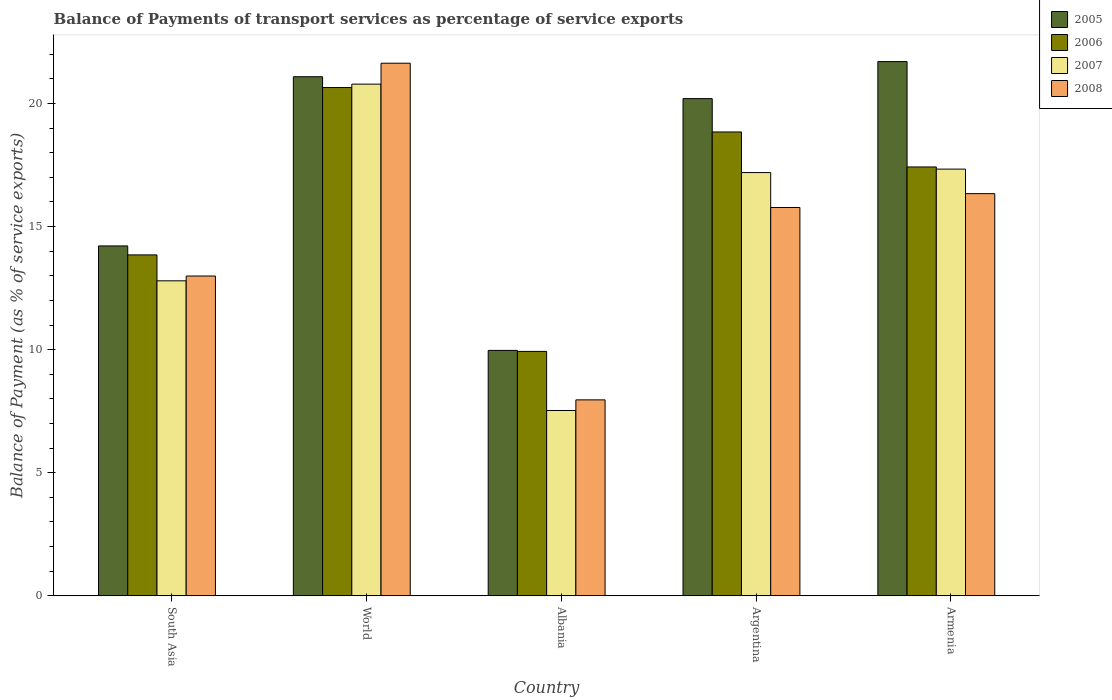How many different coloured bars are there?
Provide a short and direct response. 4. How many groups of bars are there?
Your response must be concise. 5. What is the balance of payments of transport services in 2007 in Argentina?
Ensure brevity in your answer.  17.19. Across all countries, what is the maximum balance of payments of transport services in 2008?
Make the answer very short. 21.64. Across all countries, what is the minimum balance of payments of transport services in 2007?
Offer a terse response. 7.53. In which country was the balance of payments of transport services in 2005 minimum?
Give a very brief answer. Albania. What is the total balance of payments of transport services in 2007 in the graph?
Give a very brief answer. 75.64. What is the difference between the balance of payments of transport services in 2007 in Albania and that in Armenia?
Your response must be concise. -9.81. What is the difference between the balance of payments of transport services in 2008 in South Asia and the balance of payments of transport services in 2005 in Argentina?
Keep it short and to the point. -7.21. What is the average balance of payments of transport services in 2007 per country?
Offer a very short reply. 15.13. What is the difference between the balance of payments of transport services of/in 2007 and balance of payments of transport services of/in 2005 in World?
Offer a terse response. -0.3. What is the ratio of the balance of payments of transport services in 2006 in Argentina to that in South Asia?
Offer a terse response. 1.36. What is the difference between the highest and the second highest balance of payments of transport services in 2008?
Your answer should be very brief. -5.3. What is the difference between the highest and the lowest balance of payments of transport services in 2006?
Ensure brevity in your answer.  10.72. In how many countries, is the balance of payments of transport services in 2006 greater than the average balance of payments of transport services in 2006 taken over all countries?
Keep it short and to the point. 3. Is the sum of the balance of payments of transport services in 2008 in Argentina and World greater than the maximum balance of payments of transport services in 2006 across all countries?
Your response must be concise. Yes. What does the 2nd bar from the right in World represents?
Give a very brief answer. 2007. What is the difference between two consecutive major ticks on the Y-axis?
Make the answer very short. 5. Are the values on the major ticks of Y-axis written in scientific E-notation?
Offer a very short reply. No. Does the graph contain any zero values?
Provide a short and direct response. No. Does the graph contain grids?
Provide a succinct answer. No. Where does the legend appear in the graph?
Ensure brevity in your answer.  Top right. How are the legend labels stacked?
Provide a short and direct response. Vertical. What is the title of the graph?
Ensure brevity in your answer.  Balance of Payments of transport services as percentage of service exports. Does "1979" appear as one of the legend labels in the graph?
Offer a very short reply. No. What is the label or title of the Y-axis?
Your answer should be very brief. Balance of Payment (as % of service exports). What is the Balance of Payment (as % of service exports) in 2005 in South Asia?
Provide a short and direct response. 14.21. What is the Balance of Payment (as % of service exports) of 2006 in South Asia?
Keep it short and to the point. 13.85. What is the Balance of Payment (as % of service exports) in 2007 in South Asia?
Your response must be concise. 12.8. What is the Balance of Payment (as % of service exports) of 2008 in South Asia?
Offer a very short reply. 12.99. What is the Balance of Payment (as % of service exports) in 2005 in World?
Your response must be concise. 21.09. What is the Balance of Payment (as % of service exports) in 2006 in World?
Your answer should be very brief. 20.65. What is the Balance of Payment (as % of service exports) of 2007 in World?
Offer a very short reply. 20.79. What is the Balance of Payment (as % of service exports) of 2008 in World?
Ensure brevity in your answer.  21.64. What is the Balance of Payment (as % of service exports) of 2005 in Albania?
Give a very brief answer. 9.97. What is the Balance of Payment (as % of service exports) in 2006 in Albania?
Ensure brevity in your answer.  9.93. What is the Balance of Payment (as % of service exports) of 2007 in Albania?
Offer a very short reply. 7.53. What is the Balance of Payment (as % of service exports) in 2008 in Albania?
Your answer should be compact. 7.96. What is the Balance of Payment (as % of service exports) of 2005 in Argentina?
Your answer should be very brief. 20.2. What is the Balance of Payment (as % of service exports) in 2006 in Argentina?
Your answer should be very brief. 18.84. What is the Balance of Payment (as % of service exports) of 2007 in Argentina?
Offer a very short reply. 17.19. What is the Balance of Payment (as % of service exports) in 2008 in Argentina?
Your answer should be compact. 15.78. What is the Balance of Payment (as % of service exports) in 2005 in Armenia?
Provide a short and direct response. 21.7. What is the Balance of Payment (as % of service exports) in 2006 in Armenia?
Make the answer very short. 17.42. What is the Balance of Payment (as % of service exports) in 2007 in Armenia?
Keep it short and to the point. 17.34. What is the Balance of Payment (as % of service exports) of 2008 in Armenia?
Keep it short and to the point. 16.34. Across all countries, what is the maximum Balance of Payment (as % of service exports) in 2005?
Your response must be concise. 21.7. Across all countries, what is the maximum Balance of Payment (as % of service exports) of 2006?
Ensure brevity in your answer.  20.65. Across all countries, what is the maximum Balance of Payment (as % of service exports) in 2007?
Ensure brevity in your answer.  20.79. Across all countries, what is the maximum Balance of Payment (as % of service exports) of 2008?
Give a very brief answer. 21.64. Across all countries, what is the minimum Balance of Payment (as % of service exports) of 2005?
Provide a short and direct response. 9.97. Across all countries, what is the minimum Balance of Payment (as % of service exports) of 2006?
Provide a succinct answer. 9.93. Across all countries, what is the minimum Balance of Payment (as % of service exports) of 2007?
Offer a terse response. 7.53. Across all countries, what is the minimum Balance of Payment (as % of service exports) in 2008?
Keep it short and to the point. 7.96. What is the total Balance of Payment (as % of service exports) in 2005 in the graph?
Give a very brief answer. 87.17. What is the total Balance of Payment (as % of service exports) in 2006 in the graph?
Keep it short and to the point. 80.69. What is the total Balance of Payment (as % of service exports) in 2007 in the graph?
Provide a short and direct response. 75.64. What is the total Balance of Payment (as % of service exports) of 2008 in the graph?
Offer a very short reply. 74.7. What is the difference between the Balance of Payment (as % of service exports) in 2005 in South Asia and that in World?
Provide a short and direct response. -6.87. What is the difference between the Balance of Payment (as % of service exports) in 2006 in South Asia and that in World?
Keep it short and to the point. -6.8. What is the difference between the Balance of Payment (as % of service exports) of 2007 in South Asia and that in World?
Give a very brief answer. -7.99. What is the difference between the Balance of Payment (as % of service exports) in 2008 in South Asia and that in World?
Your response must be concise. -8.64. What is the difference between the Balance of Payment (as % of service exports) in 2005 in South Asia and that in Albania?
Ensure brevity in your answer.  4.24. What is the difference between the Balance of Payment (as % of service exports) in 2006 in South Asia and that in Albania?
Your answer should be compact. 3.92. What is the difference between the Balance of Payment (as % of service exports) in 2007 in South Asia and that in Albania?
Keep it short and to the point. 5.27. What is the difference between the Balance of Payment (as % of service exports) of 2008 in South Asia and that in Albania?
Give a very brief answer. 5.03. What is the difference between the Balance of Payment (as % of service exports) in 2005 in South Asia and that in Argentina?
Give a very brief answer. -5.98. What is the difference between the Balance of Payment (as % of service exports) in 2006 in South Asia and that in Argentina?
Offer a terse response. -4.99. What is the difference between the Balance of Payment (as % of service exports) in 2007 in South Asia and that in Argentina?
Provide a short and direct response. -4.4. What is the difference between the Balance of Payment (as % of service exports) of 2008 in South Asia and that in Argentina?
Provide a succinct answer. -2.78. What is the difference between the Balance of Payment (as % of service exports) of 2005 in South Asia and that in Armenia?
Give a very brief answer. -7.49. What is the difference between the Balance of Payment (as % of service exports) of 2006 in South Asia and that in Armenia?
Give a very brief answer. -3.57. What is the difference between the Balance of Payment (as % of service exports) of 2007 in South Asia and that in Armenia?
Make the answer very short. -4.54. What is the difference between the Balance of Payment (as % of service exports) in 2008 in South Asia and that in Armenia?
Ensure brevity in your answer.  -3.35. What is the difference between the Balance of Payment (as % of service exports) of 2005 in World and that in Albania?
Your answer should be compact. 11.12. What is the difference between the Balance of Payment (as % of service exports) in 2006 in World and that in Albania?
Give a very brief answer. 10.72. What is the difference between the Balance of Payment (as % of service exports) in 2007 in World and that in Albania?
Provide a short and direct response. 13.26. What is the difference between the Balance of Payment (as % of service exports) in 2008 in World and that in Albania?
Give a very brief answer. 13.68. What is the difference between the Balance of Payment (as % of service exports) of 2005 in World and that in Argentina?
Provide a short and direct response. 0.89. What is the difference between the Balance of Payment (as % of service exports) of 2006 in World and that in Argentina?
Offer a very short reply. 1.8. What is the difference between the Balance of Payment (as % of service exports) of 2007 in World and that in Argentina?
Your answer should be compact. 3.59. What is the difference between the Balance of Payment (as % of service exports) of 2008 in World and that in Argentina?
Provide a short and direct response. 5.86. What is the difference between the Balance of Payment (as % of service exports) in 2005 in World and that in Armenia?
Your answer should be very brief. -0.62. What is the difference between the Balance of Payment (as % of service exports) in 2006 in World and that in Armenia?
Offer a very short reply. 3.23. What is the difference between the Balance of Payment (as % of service exports) in 2007 in World and that in Armenia?
Offer a terse response. 3.45. What is the difference between the Balance of Payment (as % of service exports) of 2008 in World and that in Armenia?
Your response must be concise. 5.3. What is the difference between the Balance of Payment (as % of service exports) of 2005 in Albania and that in Argentina?
Make the answer very short. -10.23. What is the difference between the Balance of Payment (as % of service exports) in 2006 in Albania and that in Argentina?
Offer a very short reply. -8.91. What is the difference between the Balance of Payment (as % of service exports) of 2007 in Albania and that in Argentina?
Give a very brief answer. -9.67. What is the difference between the Balance of Payment (as % of service exports) of 2008 in Albania and that in Argentina?
Offer a terse response. -7.81. What is the difference between the Balance of Payment (as % of service exports) in 2005 in Albania and that in Armenia?
Your response must be concise. -11.73. What is the difference between the Balance of Payment (as % of service exports) of 2006 in Albania and that in Armenia?
Make the answer very short. -7.49. What is the difference between the Balance of Payment (as % of service exports) in 2007 in Albania and that in Armenia?
Your answer should be very brief. -9.81. What is the difference between the Balance of Payment (as % of service exports) in 2008 in Albania and that in Armenia?
Provide a succinct answer. -8.38. What is the difference between the Balance of Payment (as % of service exports) in 2005 in Argentina and that in Armenia?
Provide a succinct answer. -1.5. What is the difference between the Balance of Payment (as % of service exports) in 2006 in Argentina and that in Armenia?
Provide a succinct answer. 1.42. What is the difference between the Balance of Payment (as % of service exports) of 2007 in Argentina and that in Armenia?
Offer a very short reply. -0.14. What is the difference between the Balance of Payment (as % of service exports) in 2008 in Argentina and that in Armenia?
Your response must be concise. -0.56. What is the difference between the Balance of Payment (as % of service exports) of 2005 in South Asia and the Balance of Payment (as % of service exports) of 2006 in World?
Make the answer very short. -6.43. What is the difference between the Balance of Payment (as % of service exports) of 2005 in South Asia and the Balance of Payment (as % of service exports) of 2007 in World?
Ensure brevity in your answer.  -6.57. What is the difference between the Balance of Payment (as % of service exports) in 2005 in South Asia and the Balance of Payment (as % of service exports) in 2008 in World?
Give a very brief answer. -7.42. What is the difference between the Balance of Payment (as % of service exports) of 2006 in South Asia and the Balance of Payment (as % of service exports) of 2007 in World?
Give a very brief answer. -6.94. What is the difference between the Balance of Payment (as % of service exports) in 2006 in South Asia and the Balance of Payment (as % of service exports) in 2008 in World?
Make the answer very short. -7.79. What is the difference between the Balance of Payment (as % of service exports) in 2007 in South Asia and the Balance of Payment (as % of service exports) in 2008 in World?
Provide a short and direct response. -8.84. What is the difference between the Balance of Payment (as % of service exports) in 2005 in South Asia and the Balance of Payment (as % of service exports) in 2006 in Albania?
Give a very brief answer. 4.28. What is the difference between the Balance of Payment (as % of service exports) in 2005 in South Asia and the Balance of Payment (as % of service exports) in 2007 in Albania?
Offer a very short reply. 6.68. What is the difference between the Balance of Payment (as % of service exports) in 2005 in South Asia and the Balance of Payment (as % of service exports) in 2008 in Albania?
Your answer should be compact. 6.25. What is the difference between the Balance of Payment (as % of service exports) in 2006 in South Asia and the Balance of Payment (as % of service exports) in 2007 in Albania?
Your answer should be very brief. 6.32. What is the difference between the Balance of Payment (as % of service exports) of 2006 in South Asia and the Balance of Payment (as % of service exports) of 2008 in Albania?
Offer a terse response. 5.89. What is the difference between the Balance of Payment (as % of service exports) of 2007 in South Asia and the Balance of Payment (as % of service exports) of 2008 in Albania?
Give a very brief answer. 4.84. What is the difference between the Balance of Payment (as % of service exports) in 2005 in South Asia and the Balance of Payment (as % of service exports) in 2006 in Argentina?
Ensure brevity in your answer.  -4.63. What is the difference between the Balance of Payment (as % of service exports) in 2005 in South Asia and the Balance of Payment (as % of service exports) in 2007 in Argentina?
Give a very brief answer. -2.98. What is the difference between the Balance of Payment (as % of service exports) of 2005 in South Asia and the Balance of Payment (as % of service exports) of 2008 in Argentina?
Offer a terse response. -1.56. What is the difference between the Balance of Payment (as % of service exports) of 2006 in South Asia and the Balance of Payment (as % of service exports) of 2007 in Argentina?
Make the answer very short. -3.34. What is the difference between the Balance of Payment (as % of service exports) in 2006 in South Asia and the Balance of Payment (as % of service exports) in 2008 in Argentina?
Keep it short and to the point. -1.93. What is the difference between the Balance of Payment (as % of service exports) in 2007 in South Asia and the Balance of Payment (as % of service exports) in 2008 in Argentina?
Make the answer very short. -2.98. What is the difference between the Balance of Payment (as % of service exports) in 2005 in South Asia and the Balance of Payment (as % of service exports) in 2006 in Armenia?
Your answer should be very brief. -3.21. What is the difference between the Balance of Payment (as % of service exports) in 2005 in South Asia and the Balance of Payment (as % of service exports) in 2007 in Armenia?
Give a very brief answer. -3.12. What is the difference between the Balance of Payment (as % of service exports) of 2005 in South Asia and the Balance of Payment (as % of service exports) of 2008 in Armenia?
Offer a very short reply. -2.12. What is the difference between the Balance of Payment (as % of service exports) of 2006 in South Asia and the Balance of Payment (as % of service exports) of 2007 in Armenia?
Offer a very short reply. -3.49. What is the difference between the Balance of Payment (as % of service exports) in 2006 in South Asia and the Balance of Payment (as % of service exports) in 2008 in Armenia?
Provide a succinct answer. -2.49. What is the difference between the Balance of Payment (as % of service exports) of 2007 in South Asia and the Balance of Payment (as % of service exports) of 2008 in Armenia?
Provide a succinct answer. -3.54. What is the difference between the Balance of Payment (as % of service exports) of 2005 in World and the Balance of Payment (as % of service exports) of 2006 in Albania?
Your answer should be compact. 11.16. What is the difference between the Balance of Payment (as % of service exports) of 2005 in World and the Balance of Payment (as % of service exports) of 2007 in Albania?
Ensure brevity in your answer.  13.56. What is the difference between the Balance of Payment (as % of service exports) in 2005 in World and the Balance of Payment (as % of service exports) in 2008 in Albania?
Your answer should be very brief. 13.13. What is the difference between the Balance of Payment (as % of service exports) in 2006 in World and the Balance of Payment (as % of service exports) in 2007 in Albania?
Offer a terse response. 13.12. What is the difference between the Balance of Payment (as % of service exports) of 2006 in World and the Balance of Payment (as % of service exports) of 2008 in Albania?
Offer a very short reply. 12.69. What is the difference between the Balance of Payment (as % of service exports) of 2007 in World and the Balance of Payment (as % of service exports) of 2008 in Albania?
Offer a very short reply. 12.83. What is the difference between the Balance of Payment (as % of service exports) of 2005 in World and the Balance of Payment (as % of service exports) of 2006 in Argentina?
Your answer should be very brief. 2.24. What is the difference between the Balance of Payment (as % of service exports) of 2005 in World and the Balance of Payment (as % of service exports) of 2007 in Argentina?
Provide a short and direct response. 3.89. What is the difference between the Balance of Payment (as % of service exports) in 2005 in World and the Balance of Payment (as % of service exports) in 2008 in Argentina?
Your response must be concise. 5.31. What is the difference between the Balance of Payment (as % of service exports) in 2006 in World and the Balance of Payment (as % of service exports) in 2007 in Argentina?
Provide a short and direct response. 3.45. What is the difference between the Balance of Payment (as % of service exports) in 2006 in World and the Balance of Payment (as % of service exports) in 2008 in Argentina?
Provide a succinct answer. 4.87. What is the difference between the Balance of Payment (as % of service exports) of 2007 in World and the Balance of Payment (as % of service exports) of 2008 in Argentina?
Provide a succinct answer. 5.01. What is the difference between the Balance of Payment (as % of service exports) of 2005 in World and the Balance of Payment (as % of service exports) of 2006 in Armenia?
Your answer should be very brief. 3.67. What is the difference between the Balance of Payment (as % of service exports) of 2005 in World and the Balance of Payment (as % of service exports) of 2007 in Armenia?
Provide a short and direct response. 3.75. What is the difference between the Balance of Payment (as % of service exports) of 2005 in World and the Balance of Payment (as % of service exports) of 2008 in Armenia?
Provide a succinct answer. 4.75. What is the difference between the Balance of Payment (as % of service exports) of 2006 in World and the Balance of Payment (as % of service exports) of 2007 in Armenia?
Your response must be concise. 3.31. What is the difference between the Balance of Payment (as % of service exports) in 2006 in World and the Balance of Payment (as % of service exports) in 2008 in Armenia?
Your answer should be very brief. 4.31. What is the difference between the Balance of Payment (as % of service exports) in 2007 in World and the Balance of Payment (as % of service exports) in 2008 in Armenia?
Your answer should be very brief. 4.45. What is the difference between the Balance of Payment (as % of service exports) of 2005 in Albania and the Balance of Payment (as % of service exports) of 2006 in Argentina?
Provide a succinct answer. -8.87. What is the difference between the Balance of Payment (as % of service exports) in 2005 in Albania and the Balance of Payment (as % of service exports) in 2007 in Argentina?
Provide a short and direct response. -7.22. What is the difference between the Balance of Payment (as % of service exports) of 2005 in Albania and the Balance of Payment (as % of service exports) of 2008 in Argentina?
Provide a short and direct response. -5.8. What is the difference between the Balance of Payment (as % of service exports) in 2006 in Albania and the Balance of Payment (as % of service exports) in 2007 in Argentina?
Offer a terse response. -7.26. What is the difference between the Balance of Payment (as % of service exports) of 2006 in Albania and the Balance of Payment (as % of service exports) of 2008 in Argentina?
Your answer should be compact. -5.85. What is the difference between the Balance of Payment (as % of service exports) of 2007 in Albania and the Balance of Payment (as % of service exports) of 2008 in Argentina?
Ensure brevity in your answer.  -8.25. What is the difference between the Balance of Payment (as % of service exports) in 2005 in Albania and the Balance of Payment (as % of service exports) in 2006 in Armenia?
Provide a succinct answer. -7.45. What is the difference between the Balance of Payment (as % of service exports) of 2005 in Albania and the Balance of Payment (as % of service exports) of 2007 in Armenia?
Your answer should be very brief. -7.37. What is the difference between the Balance of Payment (as % of service exports) of 2005 in Albania and the Balance of Payment (as % of service exports) of 2008 in Armenia?
Offer a terse response. -6.37. What is the difference between the Balance of Payment (as % of service exports) of 2006 in Albania and the Balance of Payment (as % of service exports) of 2007 in Armenia?
Offer a very short reply. -7.41. What is the difference between the Balance of Payment (as % of service exports) in 2006 in Albania and the Balance of Payment (as % of service exports) in 2008 in Armenia?
Make the answer very short. -6.41. What is the difference between the Balance of Payment (as % of service exports) of 2007 in Albania and the Balance of Payment (as % of service exports) of 2008 in Armenia?
Your response must be concise. -8.81. What is the difference between the Balance of Payment (as % of service exports) of 2005 in Argentina and the Balance of Payment (as % of service exports) of 2006 in Armenia?
Offer a very short reply. 2.78. What is the difference between the Balance of Payment (as % of service exports) in 2005 in Argentina and the Balance of Payment (as % of service exports) in 2007 in Armenia?
Your answer should be very brief. 2.86. What is the difference between the Balance of Payment (as % of service exports) of 2005 in Argentina and the Balance of Payment (as % of service exports) of 2008 in Armenia?
Your answer should be very brief. 3.86. What is the difference between the Balance of Payment (as % of service exports) of 2006 in Argentina and the Balance of Payment (as % of service exports) of 2007 in Armenia?
Your answer should be very brief. 1.51. What is the difference between the Balance of Payment (as % of service exports) of 2006 in Argentina and the Balance of Payment (as % of service exports) of 2008 in Armenia?
Your answer should be very brief. 2.51. What is the difference between the Balance of Payment (as % of service exports) in 2007 in Argentina and the Balance of Payment (as % of service exports) in 2008 in Armenia?
Keep it short and to the point. 0.86. What is the average Balance of Payment (as % of service exports) of 2005 per country?
Provide a short and direct response. 17.43. What is the average Balance of Payment (as % of service exports) of 2006 per country?
Keep it short and to the point. 16.14. What is the average Balance of Payment (as % of service exports) in 2007 per country?
Provide a short and direct response. 15.13. What is the average Balance of Payment (as % of service exports) in 2008 per country?
Provide a short and direct response. 14.94. What is the difference between the Balance of Payment (as % of service exports) of 2005 and Balance of Payment (as % of service exports) of 2006 in South Asia?
Provide a succinct answer. 0.36. What is the difference between the Balance of Payment (as % of service exports) of 2005 and Balance of Payment (as % of service exports) of 2007 in South Asia?
Give a very brief answer. 1.42. What is the difference between the Balance of Payment (as % of service exports) of 2005 and Balance of Payment (as % of service exports) of 2008 in South Asia?
Ensure brevity in your answer.  1.22. What is the difference between the Balance of Payment (as % of service exports) in 2006 and Balance of Payment (as % of service exports) in 2007 in South Asia?
Provide a short and direct response. 1.05. What is the difference between the Balance of Payment (as % of service exports) of 2006 and Balance of Payment (as % of service exports) of 2008 in South Asia?
Your response must be concise. 0.86. What is the difference between the Balance of Payment (as % of service exports) of 2007 and Balance of Payment (as % of service exports) of 2008 in South Asia?
Your response must be concise. -0.19. What is the difference between the Balance of Payment (as % of service exports) in 2005 and Balance of Payment (as % of service exports) in 2006 in World?
Your answer should be very brief. 0.44. What is the difference between the Balance of Payment (as % of service exports) in 2005 and Balance of Payment (as % of service exports) in 2007 in World?
Provide a succinct answer. 0.3. What is the difference between the Balance of Payment (as % of service exports) of 2005 and Balance of Payment (as % of service exports) of 2008 in World?
Ensure brevity in your answer.  -0.55. What is the difference between the Balance of Payment (as % of service exports) in 2006 and Balance of Payment (as % of service exports) in 2007 in World?
Provide a short and direct response. -0.14. What is the difference between the Balance of Payment (as % of service exports) in 2006 and Balance of Payment (as % of service exports) in 2008 in World?
Give a very brief answer. -0.99. What is the difference between the Balance of Payment (as % of service exports) of 2007 and Balance of Payment (as % of service exports) of 2008 in World?
Your answer should be very brief. -0.85. What is the difference between the Balance of Payment (as % of service exports) of 2005 and Balance of Payment (as % of service exports) of 2006 in Albania?
Ensure brevity in your answer.  0.04. What is the difference between the Balance of Payment (as % of service exports) of 2005 and Balance of Payment (as % of service exports) of 2007 in Albania?
Offer a very short reply. 2.44. What is the difference between the Balance of Payment (as % of service exports) in 2005 and Balance of Payment (as % of service exports) in 2008 in Albania?
Make the answer very short. 2.01. What is the difference between the Balance of Payment (as % of service exports) in 2006 and Balance of Payment (as % of service exports) in 2007 in Albania?
Provide a succinct answer. 2.4. What is the difference between the Balance of Payment (as % of service exports) of 2006 and Balance of Payment (as % of service exports) of 2008 in Albania?
Make the answer very short. 1.97. What is the difference between the Balance of Payment (as % of service exports) in 2007 and Balance of Payment (as % of service exports) in 2008 in Albania?
Make the answer very short. -0.43. What is the difference between the Balance of Payment (as % of service exports) of 2005 and Balance of Payment (as % of service exports) of 2006 in Argentina?
Offer a terse response. 1.35. What is the difference between the Balance of Payment (as % of service exports) in 2005 and Balance of Payment (as % of service exports) in 2007 in Argentina?
Your answer should be compact. 3. What is the difference between the Balance of Payment (as % of service exports) in 2005 and Balance of Payment (as % of service exports) in 2008 in Argentina?
Make the answer very short. 4.42. What is the difference between the Balance of Payment (as % of service exports) of 2006 and Balance of Payment (as % of service exports) of 2007 in Argentina?
Offer a terse response. 1.65. What is the difference between the Balance of Payment (as % of service exports) of 2006 and Balance of Payment (as % of service exports) of 2008 in Argentina?
Your answer should be very brief. 3.07. What is the difference between the Balance of Payment (as % of service exports) in 2007 and Balance of Payment (as % of service exports) in 2008 in Argentina?
Make the answer very short. 1.42. What is the difference between the Balance of Payment (as % of service exports) in 2005 and Balance of Payment (as % of service exports) in 2006 in Armenia?
Keep it short and to the point. 4.28. What is the difference between the Balance of Payment (as % of service exports) in 2005 and Balance of Payment (as % of service exports) in 2007 in Armenia?
Provide a short and direct response. 4.37. What is the difference between the Balance of Payment (as % of service exports) in 2005 and Balance of Payment (as % of service exports) in 2008 in Armenia?
Give a very brief answer. 5.36. What is the difference between the Balance of Payment (as % of service exports) of 2006 and Balance of Payment (as % of service exports) of 2007 in Armenia?
Give a very brief answer. 0.09. What is the difference between the Balance of Payment (as % of service exports) of 2006 and Balance of Payment (as % of service exports) of 2008 in Armenia?
Give a very brief answer. 1.08. What is the ratio of the Balance of Payment (as % of service exports) of 2005 in South Asia to that in World?
Provide a succinct answer. 0.67. What is the ratio of the Balance of Payment (as % of service exports) in 2006 in South Asia to that in World?
Keep it short and to the point. 0.67. What is the ratio of the Balance of Payment (as % of service exports) of 2007 in South Asia to that in World?
Give a very brief answer. 0.62. What is the ratio of the Balance of Payment (as % of service exports) of 2008 in South Asia to that in World?
Provide a succinct answer. 0.6. What is the ratio of the Balance of Payment (as % of service exports) in 2005 in South Asia to that in Albania?
Provide a succinct answer. 1.43. What is the ratio of the Balance of Payment (as % of service exports) in 2006 in South Asia to that in Albania?
Offer a very short reply. 1.39. What is the ratio of the Balance of Payment (as % of service exports) in 2007 in South Asia to that in Albania?
Your response must be concise. 1.7. What is the ratio of the Balance of Payment (as % of service exports) in 2008 in South Asia to that in Albania?
Make the answer very short. 1.63. What is the ratio of the Balance of Payment (as % of service exports) of 2005 in South Asia to that in Argentina?
Provide a succinct answer. 0.7. What is the ratio of the Balance of Payment (as % of service exports) in 2006 in South Asia to that in Argentina?
Give a very brief answer. 0.73. What is the ratio of the Balance of Payment (as % of service exports) in 2007 in South Asia to that in Argentina?
Provide a short and direct response. 0.74. What is the ratio of the Balance of Payment (as % of service exports) in 2008 in South Asia to that in Argentina?
Make the answer very short. 0.82. What is the ratio of the Balance of Payment (as % of service exports) in 2005 in South Asia to that in Armenia?
Give a very brief answer. 0.65. What is the ratio of the Balance of Payment (as % of service exports) in 2006 in South Asia to that in Armenia?
Your answer should be compact. 0.8. What is the ratio of the Balance of Payment (as % of service exports) of 2007 in South Asia to that in Armenia?
Give a very brief answer. 0.74. What is the ratio of the Balance of Payment (as % of service exports) of 2008 in South Asia to that in Armenia?
Provide a succinct answer. 0.8. What is the ratio of the Balance of Payment (as % of service exports) of 2005 in World to that in Albania?
Your answer should be compact. 2.12. What is the ratio of the Balance of Payment (as % of service exports) of 2006 in World to that in Albania?
Ensure brevity in your answer.  2.08. What is the ratio of the Balance of Payment (as % of service exports) in 2007 in World to that in Albania?
Ensure brevity in your answer.  2.76. What is the ratio of the Balance of Payment (as % of service exports) of 2008 in World to that in Albania?
Give a very brief answer. 2.72. What is the ratio of the Balance of Payment (as % of service exports) in 2005 in World to that in Argentina?
Keep it short and to the point. 1.04. What is the ratio of the Balance of Payment (as % of service exports) in 2006 in World to that in Argentina?
Make the answer very short. 1.1. What is the ratio of the Balance of Payment (as % of service exports) in 2007 in World to that in Argentina?
Your answer should be very brief. 1.21. What is the ratio of the Balance of Payment (as % of service exports) of 2008 in World to that in Argentina?
Give a very brief answer. 1.37. What is the ratio of the Balance of Payment (as % of service exports) in 2005 in World to that in Armenia?
Keep it short and to the point. 0.97. What is the ratio of the Balance of Payment (as % of service exports) of 2006 in World to that in Armenia?
Your answer should be very brief. 1.19. What is the ratio of the Balance of Payment (as % of service exports) in 2007 in World to that in Armenia?
Your response must be concise. 1.2. What is the ratio of the Balance of Payment (as % of service exports) of 2008 in World to that in Armenia?
Your answer should be compact. 1.32. What is the ratio of the Balance of Payment (as % of service exports) of 2005 in Albania to that in Argentina?
Keep it short and to the point. 0.49. What is the ratio of the Balance of Payment (as % of service exports) in 2006 in Albania to that in Argentina?
Provide a short and direct response. 0.53. What is the ratio of the Balance of Payment (as % of service exports) in 2007 in Albania to that in Argentina?
Provide a succinct answer. 0.44. What is the ratio of the Balance of Payment (as % of service exports) in 2008 in Albania to that in Argentina?
Your answer should be compact. 0.5. What is the ratio of the Balance of Payment (as % of service exports) in 2005 in Albania to that in Armenia?
Keep it short and to the point. 0.46. What is the ratio of the Balance of Payment (as % of service exports) of 2006 in Albania to that in Armenia?
Ensure brevity in your answer.  0.57. What is the ratio of the Balance of Payment (as % of service exports) in 2007 in Albania to that in Armenia?
Your answer should be very brief. 0.43. What is the ratio of the Balance of Payment (as % of service exports) of 2008 in Albania to that in Armenia?
Provide a short and direct response. 0.49. What is the ratio of the Balance of Payment (as % of service exports) in 2005 in Argentina to that in Armenia?
Provide a succinct answer. 0.93. What is the ratio of the Balance of Payment (as % of service exports) in 2006 in Argentina to that in Armenia?
Provide a short and direct response. 1.08. What is the ratio of the Balance of Payment (as % of service exports) of 2007 in Argentina to that in Armenia?
Your answer should be compact. 0.99. What is the ratio of the Balance of Payment (as % of service exports) of 2008 in Argentina to that in Armenia?
Offer a terse response. 0.97. What is the difference between the highest and the second highest Balance of Payment (as % of service exports) of 2005?
Make the answer very short. 0.62. What is the difference between the highest and the second highest Balance of Payment (as % of service exports) in 2006?
Provide a short and direct response. 1.8. What is the difference between the highest and the second highest Balance of Payment (as % of service exports) in 2007?
Provide a short and direct response. 3.45. What is the difference between the highest and the second highest Balance of Payment (as % of service exports) of 2008?
Your answer should be compact. 5.3. What is the difference between the highest and the lowest Balance of Payment (as % of service exports) of 2005?
Keep it short and to the point. 11.73. What is the difference between the highest and the lowest Balance of Payment (as % of service exports) of 2006?
Your answer should be compact. 10.72. What is the difference between the highest and the lowest Balance of Payment (as % of service exports) in 2007?
Offer a terse response. 13.26. What is the difference between the highest and the lowest Balance of Payment (as % of service exports) in 2008?
Your answer should be compact. 13.68. 